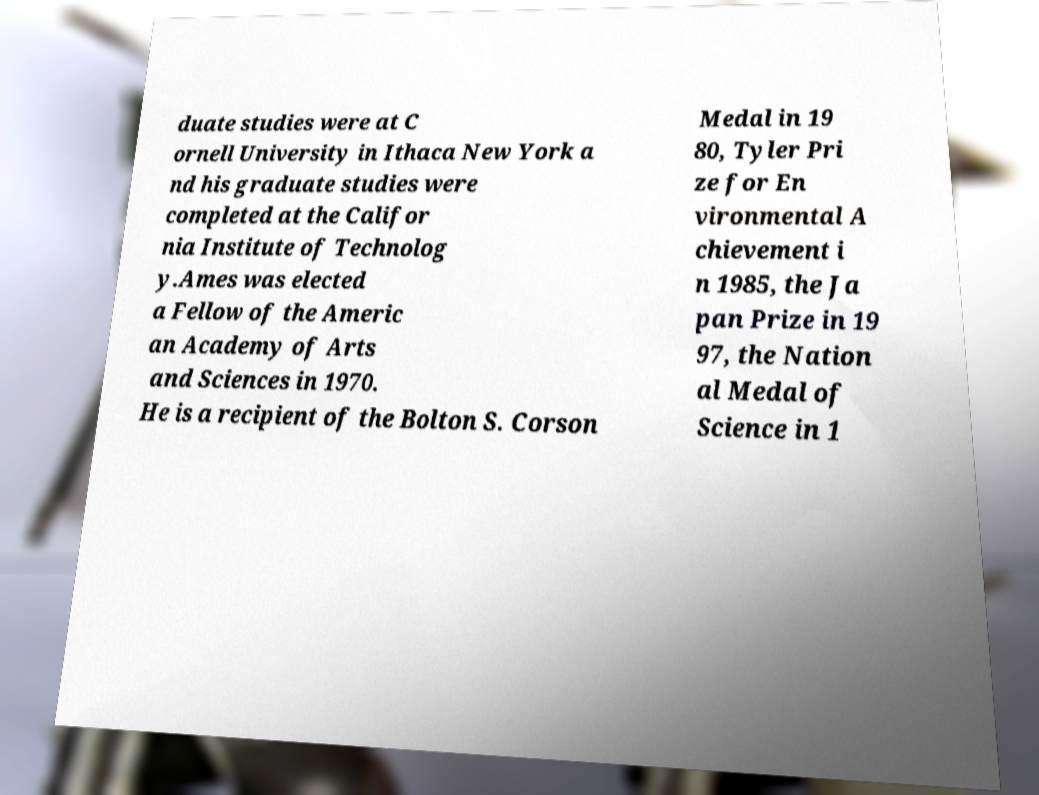What messages or text are displayed in this image? I need them in a readable, typed format. duate studies were at C ornell University in Ithaca New York a nd his graduate studies were completed at the Califor nia Institute of Technolog y.Ames was elected a Fellow of the Americ an Academy of Arts and Sciences in 1970. He is a recipient of the Bolton S. Corson Medal in 19 80, Tyler Pri ze for En vironmental A chievement i n 1985, the Ja pan Prize in 19 97, the Nation al Medal of Science in 1 